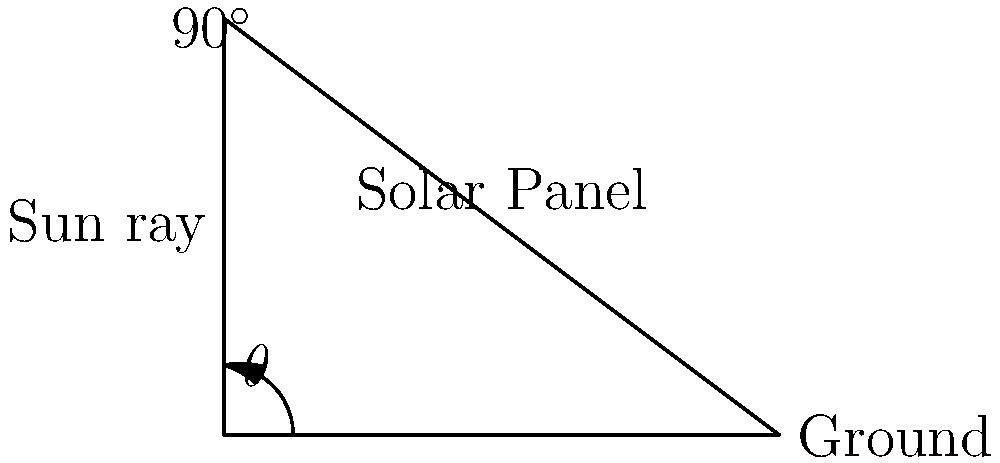An eco-friendly lodge in Winter Haven is installing solar panels to reduce its environmental impact. The solar panels need to be tilted at an optimal angle to maximize sunlight absorption. If the sun's rays hit the ground at an angle of $\theta$ degrees as shown in the diagram, what should be the tilt angle of the solar panel with respect to the ground to receive perpendicular sunlight? Let's approach this step-by-step:

1) In the diagram, we can see that the sun ray forms an angle $\theta$ with the ground.

2) For the solar panel to receive perpendicular sunlight, it must be positioned at a right angle (90°) to the sun ray.

3) We can see that the solar panel, the ground, and the sun ray form a right-angled triangle.

4) In this triangle:
   - The angle between the ground and the sun ray is $\theta$
   - The angle between the sun ray and the solar panel is 90° (for perpendicular sunlight)
   - The angle we're looking for is between the ground and the solar panel

5) In a triangle, the sum of all angles must be 180°. Therefore:

   $\theta + 90^\circ + \text{tilt angle} = 180^\circ$

6) Solving for the tilt angle:

   $\text{tilt angle} = 180^\circ - 90^\circ - \theta = 90^\circ - \theta$

Thus, to receive perpendicular sunlight, the solar panel should be tilted at an angle of $90^\circ - \theta$ with respect to the ground.
Answer: $90^\circ - \theta$ 